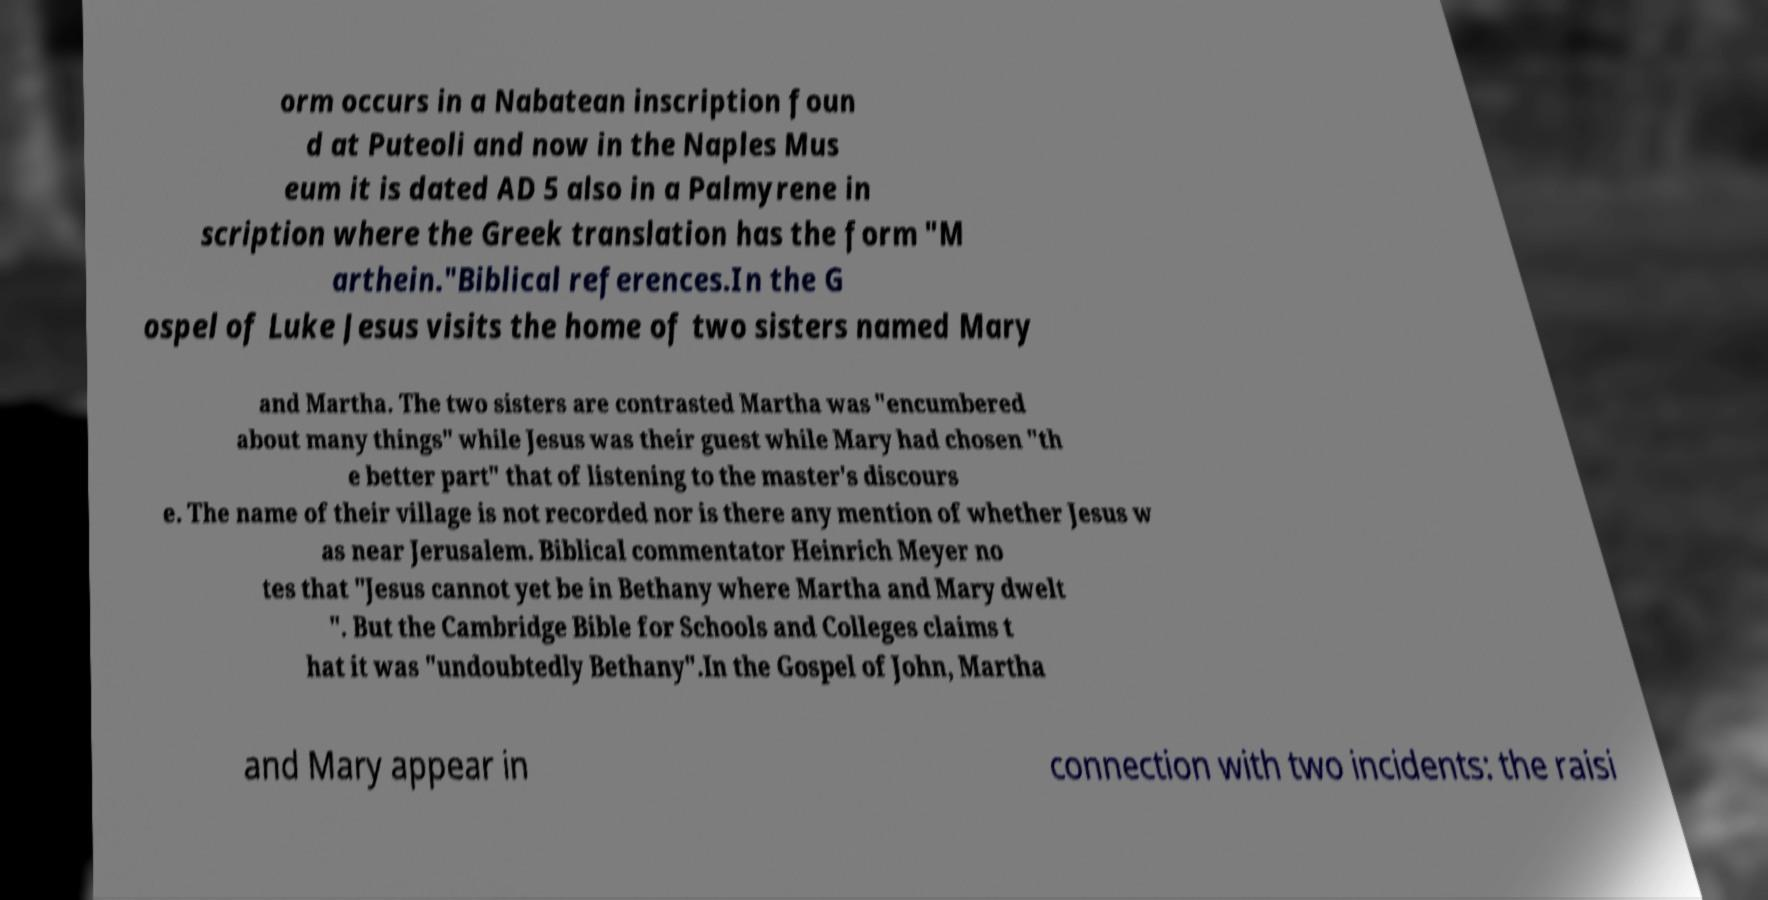Please identify and transcribe the text found in this image. orm occurs in a Nabatean inscription foun d at Puteoli and now in the Naples Mus eum it is dated AD 5 also in a Palmyrene in scription where the Greek translation has the form "M arthein."Biblical references.In the G ospel of Luke Jesus visits the home of two sisters named Mary and Martha. The two sisters are contrasted Martha was "encumbered about many things" while Jesus was their guest while Mary had chosen "th e better part" that of listening to the master's discours e. The name of their village is not recorded nor is there any mention of whether Jesus w as near Jerusalem. Biblical commentator Heinrich Meyer no tes that "Jesus cannot yet be in Bethany where Martha and Mary dwelt ". But the Cambridge Bible for Schools and Colleges claims t hat it was "undoubtedly Bethany".In the Gospel of John, Martha and Mary appear in connection with two incidents: the raisi 